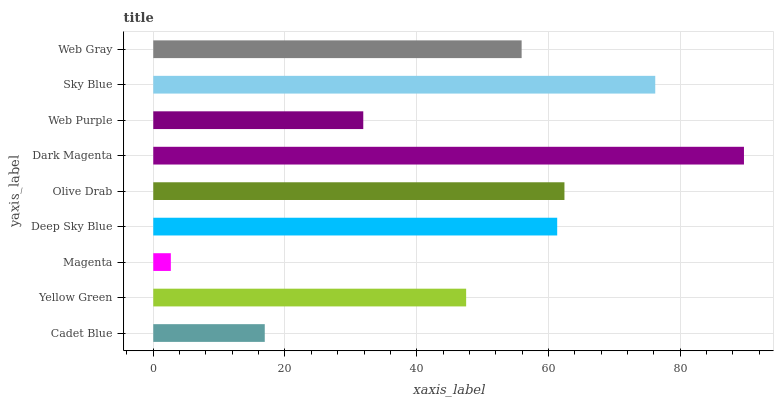Is Magenta the minimum?
Answer yes or no. Yes. Is Dark Magenta the maximum?
Answer yes or no. Yes. Is Yellow Green the minimum?
Answer yes or no. No. Is Yellow Green the maximum?
Answer yes or no. No. Is Yellow Green greater than Cadet Blue?
Answer yes or no. Yes. Is Cadet Blue less than Yellow Green?
Answer yes or no. Yes. Is Cadet Blue greater than Yellow Green?
Answer yes or no. No. Is Yellow Green less than Cadet Blue?
Answer yes or no. No. Is Web Gray the high median?
Answer yes or no. Yes. Is Web Gray the low median?
Answer yes or no. Yes. Is Deep Sky Blue the high median?
Answer yes or no. No. Is Olive Drab the low median?
Answer yes or no. No. 